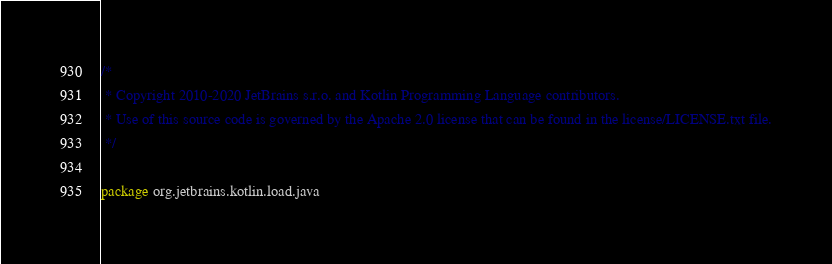<code> <loc_0><loc_0><loc_500><loc_500><_Kotlin_>/*
 * Copyright 2010-2020 JetBrains s.r.o. and Kotlin Programming Language contributors.
 * Use of this source code is governed by the Apache 2.0 license that can be found in the license/LICENSE.txt file.
 */

package org.jetbrains.kotlin.load.java
</code> 